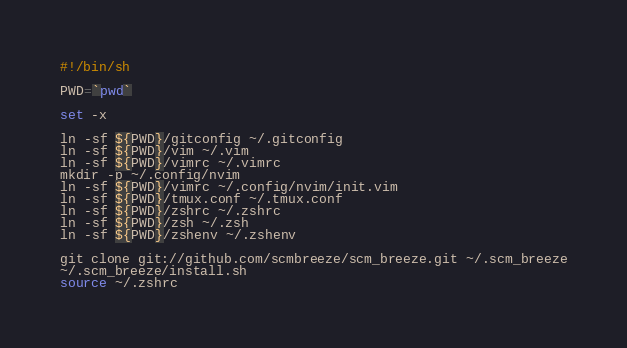<code> <loc_0><loc_0><loc_500><loc_500><_Bash_>#!/bin/sh

PWD=`pwd`

set -x

ln -sf ${PWD}/gitconfig ~/.gitconfig
ln -sf ${PWD}/vim ~/.vim
ln -sf ${PWD}/vimrc ~/.vimrc
mkdir -p ~/.config/nvim
ln -sf ${PWD}/vimrc ~/.config/nvim/init.vim
ln -sf ${PWD}/tmux.conf ~/.tmux.conf
ln -sf ${PWD}/zshrc ~/.zshrc
ln -sf ${PWD}/zsh ~/.zsh
ln -sf ${PWD}/zshenv ~/.zshenv

git clone git://github.com/scmbreeze/scm_breeze.git ~/.scm_breeze
~/.scm_breeze/install.sh
source ~/.zshrc
</code> 